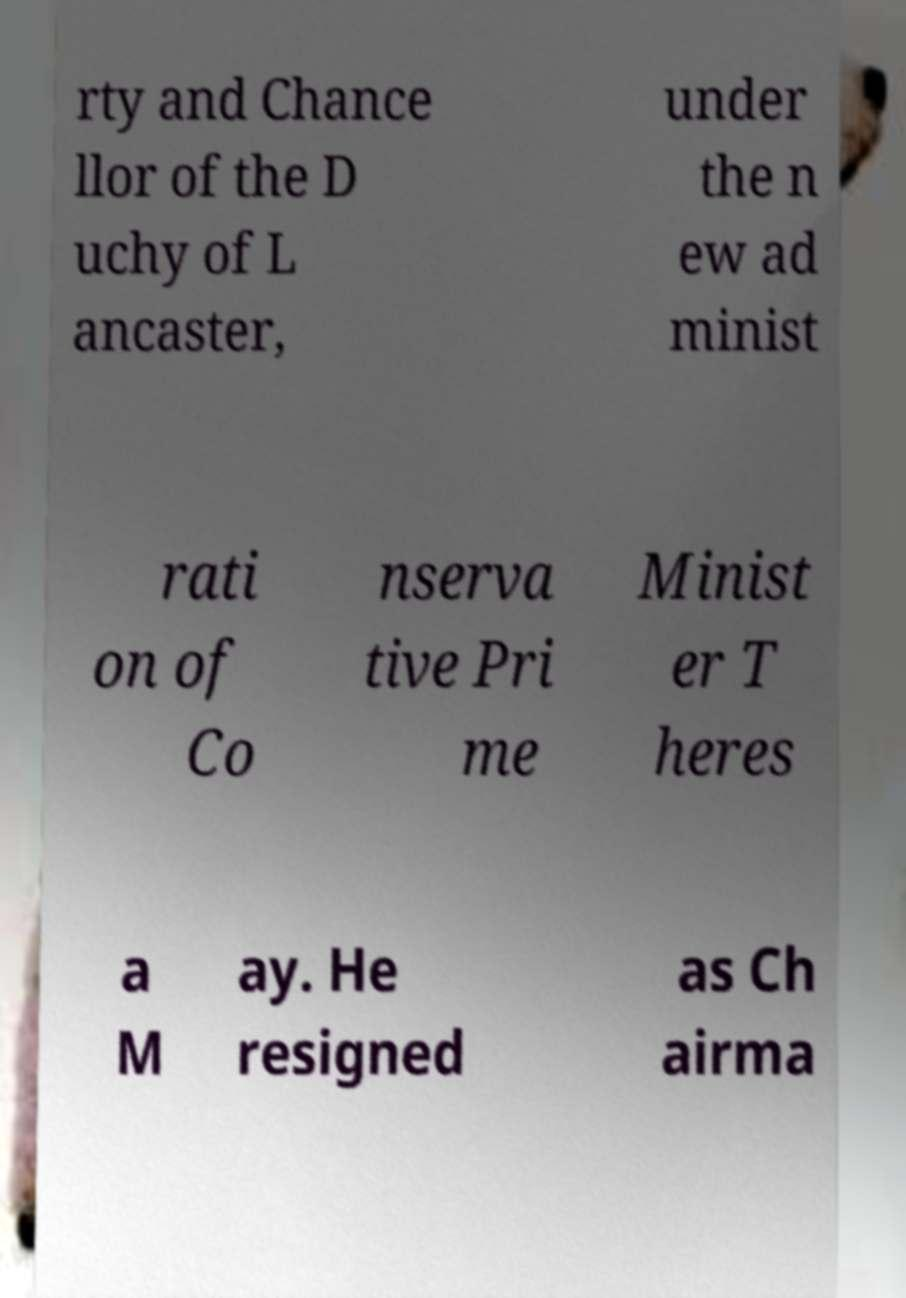For documentation purposes, I need the text within this image transcribed. Could you provide that? rty and Chance llor of the D uchy of L ancaster, under the n ew ad minist rati on of Co nserva tive Pri me Minist er T heres a M ay. He resigned as Ch airma 